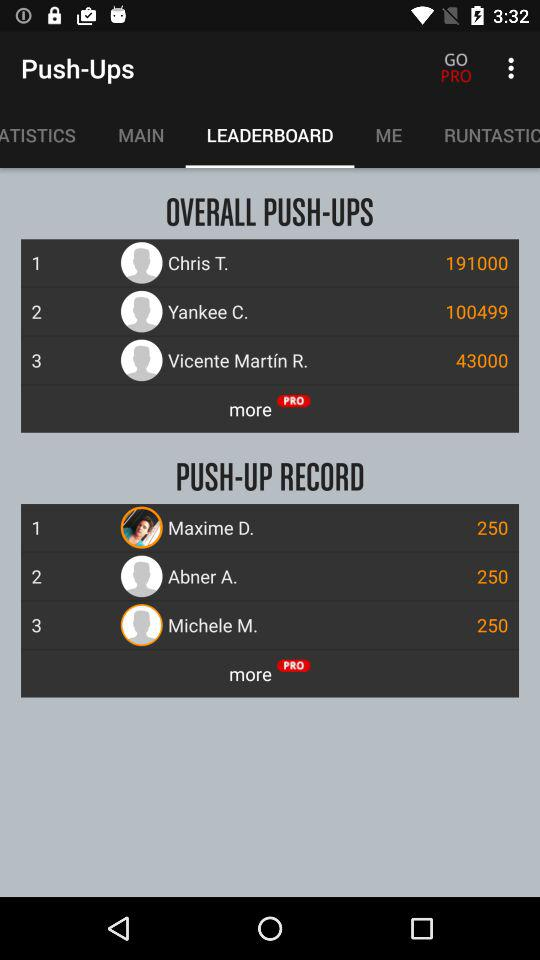How many people have more than 250 push-ups?
Answer the question using a single word or phrase. 3 